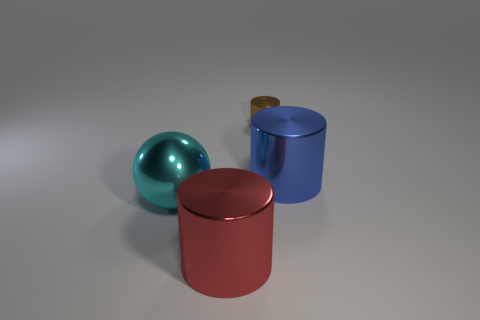Subtract all large metal cylinders. How many cylinders are left? 1 Subtract all blue cylinders. How many cylinders are left? 2 Subtract 2 cylinders. How many cylinders are left? 1 Add 1 small metallic cylinders. How many objects exist? 5 Subtract 0 green balls. How many objects are left? 4 Subtract all balls. How many objects are left? 3 Subtract all green cylinders. Subtract all brown balls. How many cylinders are left? 3 Subtract all purple balls. How many cyan cylinders are left? 0 Subtract all large cyan metallic things. Subtract all brown cylinders. How many objects are left? 2 Add 1 large cyan metal spheres. How many large cyan metal spheres are left? 2 